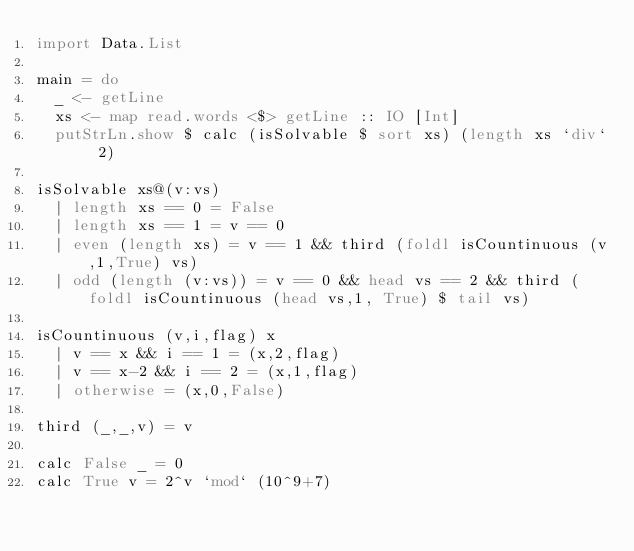<code> <loc_0><loc_0><loc_500><loc_500><_Haskell_>import Data.List

main = do
	_ <- getLine
	xs <- map read.words <$> getLine :: IO [Int]
	putStrLn.show $ calc (isSolvable $ sort xs) (length xs `div` 2)

isSolvable xs@(v:vs)
	| length xs == 0 = False
	| length xs == 1 = v == 0
	| even (length xs) = v == 1 && third (foldl isCountinuous (v,1,True) vs)
	| odd (length (v:vs)) = v == 0 && head vs == 2 && third (foldl isCountinuous (head vs,1, True) $ tail vs)

isCountinuous (v,i,flag) x 
	| v == x && i == 1 = (x,2,flag)
	| v == x-2 && i == 2 = (x,1,flag)
	| otherwise = (x,0,False)

third (_,_,v) = v

calc False _ = 0
calc True v = 2^v `mod` (10^9+7)</code> 